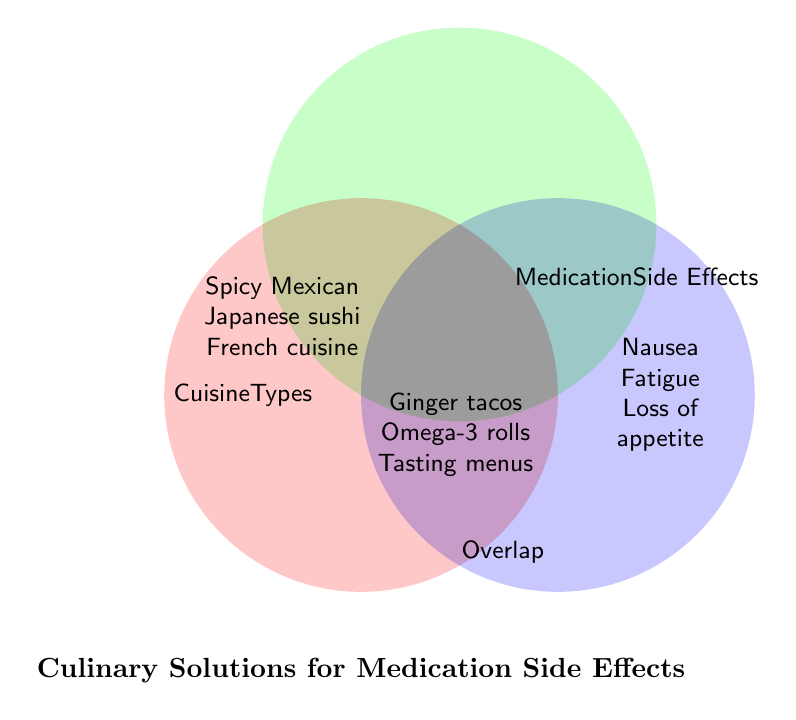What's the title of the figure? The title of the figure is located at the bottom of the diagram and reads "Culinary Solutions for Medication Side Effects."
Answer: Culinary Solutions for Medication Side Effects What are the three main sections of the Venn Diagram? The three main sections are labeled as Cuisine Types, Medication Side Effects, and Overlap, indicated by distinct colors and positions.
Answer: Cuisine Types, Medication Side Effects, Overlap Which cuisine types are included in the diagram? The cuisine types listed in the Cuisine Types section are Spicy Mexican, Japanese sushi, and French cuisine.
Answer: Spicy Mexican, Japanese sushi, French cuisine What are the side effects mentioned in the diagram? The side effects in the Medication Side Effects section are Nausea, Fatigue, and Loss of appetite.
Answer: Nausea, Fatigue, Loss of appetite Which culinary solutions are suggested for Nausea? According to the diagram, the culinary solution for Nausea involves Ginger tacos.
Answer: Ginger tacos How many culinary solutions are provided for the given side effects? The Venn Diagram provides three culinary solutions corresponding to the side effects listed.
Answer: Three What cuisine type is associated with Omega-3 rolls? Omega-3 rolls are placed in the Overlap section, associated with Japanese sushi for the side effect of Fatigue.
Answer: Japanese sushi Which side effect is tackled by suggesting small portion tasting menus? Small portion tasting menus are listed as a culinary solution for the side effect of Loss of appetite.
Answer: Loss of appetite How do Omega-3 rolls help with a specific side effect? Omega-3 rolls are listed as a culinary solution associated with reducing Fatigue, likely due to the benefits of Omega-3 fatty acids.
Answer: Reduces Fatigue Compare the cuisine options for 'Spicy Mexican' and 'French cuisine' in terms of their side effects and solutions. Spicy Mexican is connected with Nausea and suggests Ginger tacos, while French cuisine deals with Loss of appetite proposing small portion tasting menus, reflecting different sides and solutions.
Answer: Different sides & solutions 